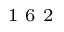<formula> <loc_0><loc_0><loc_500><loc_500>^ { 1 } 6 2</formula> 